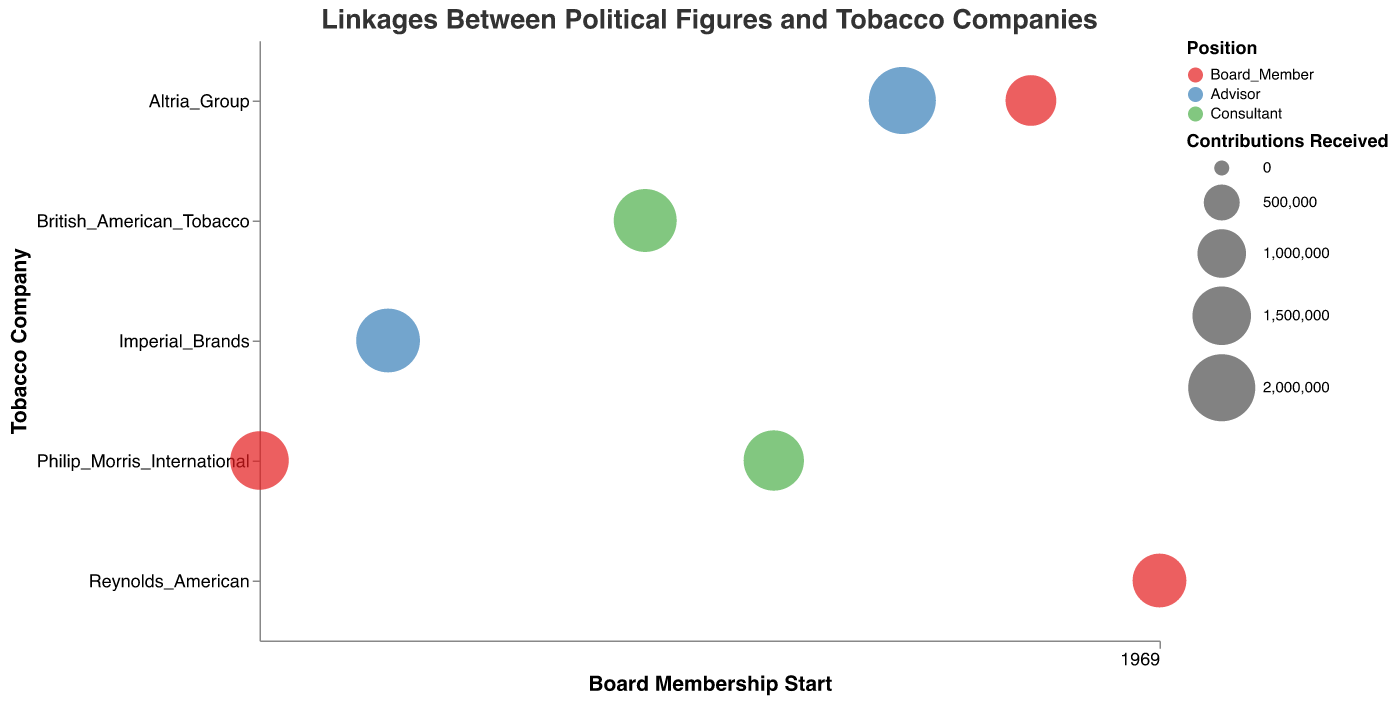How many political figures are associated with Philip Morris International? Count the number of distinct political figures listed under "Philip Morris International." There are two: John Doe and Emily Wilson.
Answer: 2 Which political figure who served as an advisor received the highest contributions? Identify all advisors first: Jane Smith and David Johnson. Compare their contributions: Jane Smith received $2,000,000 and David Johnson received $1,800,000.
Answer: Jane Smith What is the range of contributions received by the political figures in the data? Identify the minimum and maximum contributions: $1,100,000 (Michael Brown) and $2,000,000 (Jane Smith). The range is $2,000,000 - $1,100,000 = $900,000.
Answer: $900,000 Which company’s bubble appears earliest on the timeline? Look at the x-axis (Board Membership Start) and find the earliest starting year. Philip Morris International has the earliest start (2005).
Answer: Philip Morris International Comparing Emma Davis and Michael Brown, who had a longer association with their respective company, and by how many years? Emma Davis (8 years) vs Michael Brown (6 years). The difference in association years is 8 - 6 = 2 years.
Answer: Emma Davis by 2 years What is the total number of years all figures were associated with tobacco companies? Sum the "Years Associated" for all figures: 10 + 10 + 10 + 8 + 10 + 10 + 6 = 64 years.
Answer: 64 years How many companies are represented in the chart? Count the distinct companies on the y-axis: Philip Morris International, Altria Group, British American Tobacco, Reynolds American, Imperial Brands.
Answer: 5 Which political strategist associated with British American Tobacco received contributions closest to $1,750,000? Identify the contributions for figures associated with British American Tobacco. Richard Roe received $1,750,000.
Answer: Richard Roe Are there more political figures serving as Board Members or Advisors? Count Board Members: John Doe, Emma Davis, Michael Brown. Advisors: Jane Smith, David Johnson. Board Members (3) vs Advisors (2).
Answer: More Board Members What is the average amount of contributions received by political figures associated with Altria Group? Sum the contributions for figures at Altria Group: Jane Smith ($2,000,000) + Michael Brown ($1,100,000) = $3,100,000. Divide by the number of figures (2): $3,100,000 / 2 = $1,550,000.
Answer: $1,550,000 